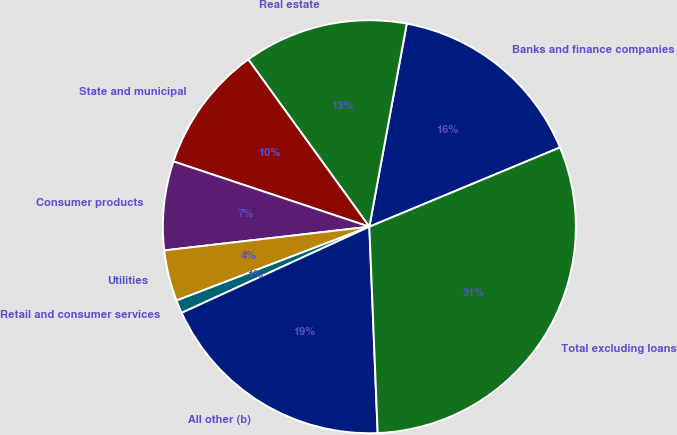<chart> <loc_0><loc_0><loc_500><loc_500><pie_chart><fcel>Banks and finance companies<fcel>Real estate<fcel>State and municipal<fcel>Consumer products<fcel>Utilities<fcel>Retail and consumer services<fcel>All other (b)<fcel>Total excluding loans<nl><fcel>15.83%<fcel>12.87%<fcel>9.91%<fcel>6.95%<fcel>3.99%<fcel>1.03%<fcel>18.79%<fcel>30.63%<nl></chart> 